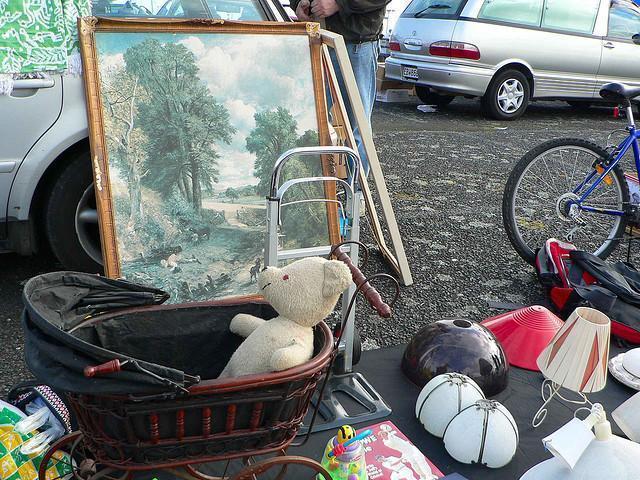This umbrellas used in which lamp?
Make your selection and explain in format: 'Answer: answer
Rationale: rationale.'
Options: Noon, day, night, evening. Answer: night.
Rationale: Lamps are used at night. 